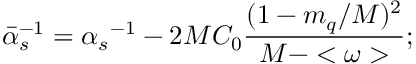Convert formula to latex. <formula><loc_0><loc_0><loc_500><loc_500>{ { \bar { \alpha } } _ { s } } ^ { - 1 } = { \alpha _ { s } } ^ { - 1 } - { 2 M C _ { 0 } } { \frac { ( 1 - m _ { q } / M ) ^ { 2 } } { M - < \omega > } } ;</formula> 